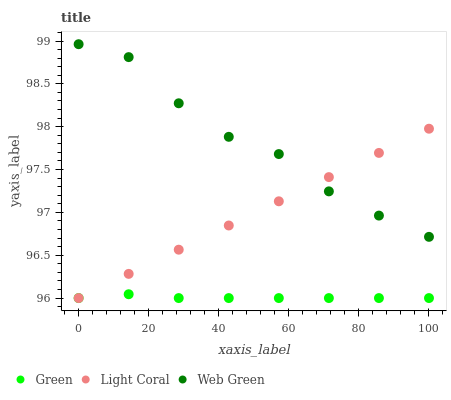Does Green have the minimum area under the curve?
Answer yes or no. Yes. Does Web Green have the maximum area under the curve?
Answer yes or no. Yes. Does Web Green have the minimum area under the curve?
Answer yes or no. No. Does Green have the maximum area under the curve?
Answer yes or no. No. Is Light Coral the smoothest?
Answer yes or no. Yes. Is Web Green the roughest?
Answer yes or no. Yes. Is Green the smoothest?
Answer yes or no. No. Is Green the roughest?
Answer yes or no. No. Does Light Coral have the lowest value?
Answer yes or no. Yes. Does Web Green have the lowest value?
Answer yes or no. No. Does Web Green have the highest value?
Answer yes or no. Yes. Does Green have the highest value?
Answer yes or no. No. Is Green less than Web Green?
Answer yes or no. Yes. Is Web Green greater than Green?
Answer yes or no. Yes. Does Light Coral intersect Green?
Answer yes or no. Yes. Is Light Coral less than Green?
Answer yes or no. No. Is Light Coral greater than Green?
Answer yes or no. No. Does Green intersect Web Green?
Answer yes or no. No. 